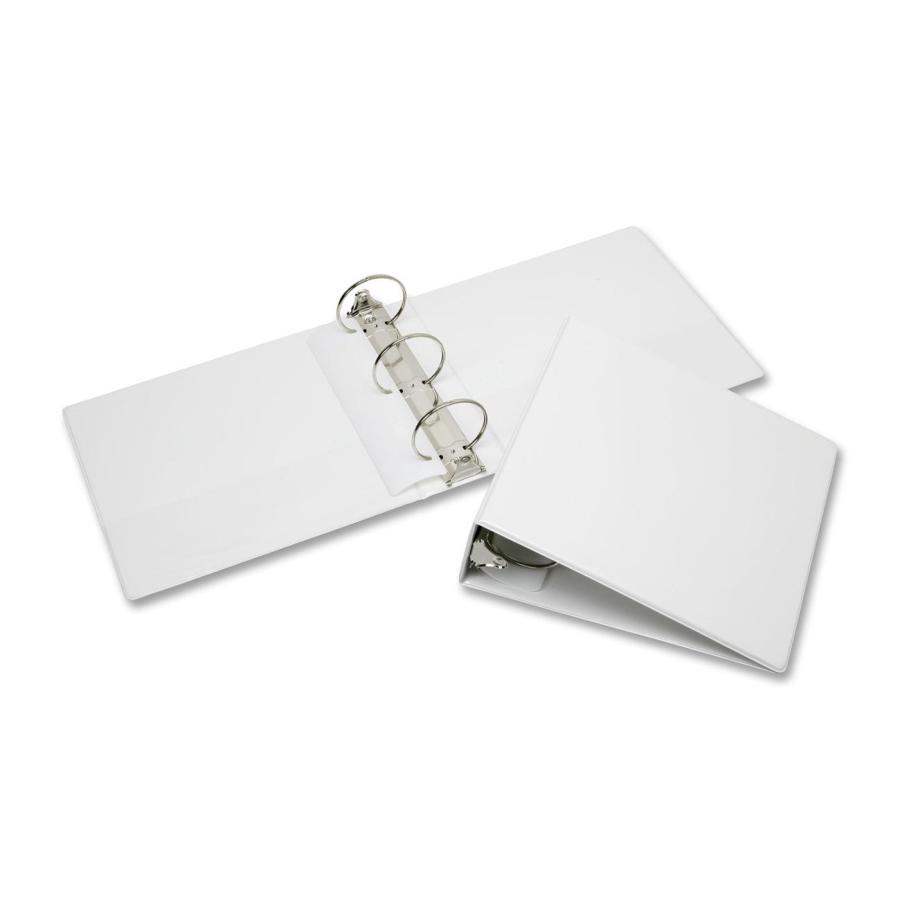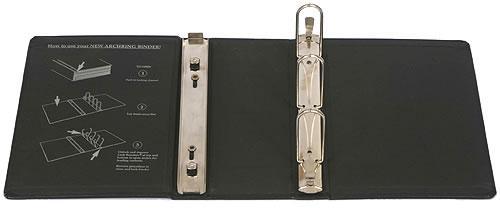The first image is the image on the left, the second image is the image on the right. Analyze the images presented: Is the assertion "All images show only black binders." valid? Answer yes or no. No. The first image is the image on the left, the second image is the image on the right. Given the left and right images, does the statement "Two white notebooks, one open and one closed, are shown in one image, while only one notebook lying flat is in the second image." hold true? Answer yes or no. Yes. 